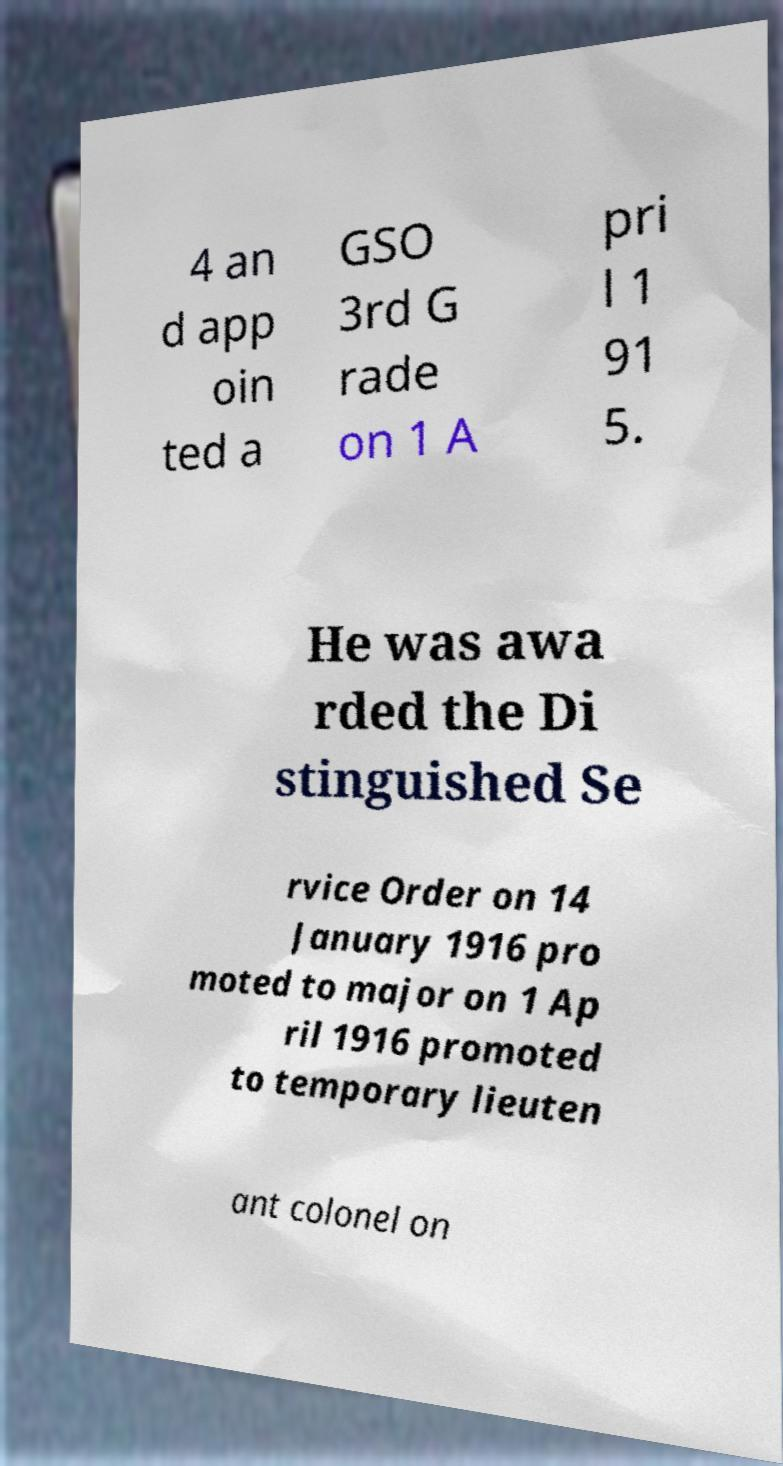Could you assist in decoding the text presented in this image and type it out clearly? 4 an d app oin ted a GSO 3rd G rade on 1 A pri l 1 91 5. He was awa rded the Di stinguished Se rvice Order on 14 January 1916 pro moted to major on 1 Ap ril 1916 promoted to temporary lieuten ant colonel on 